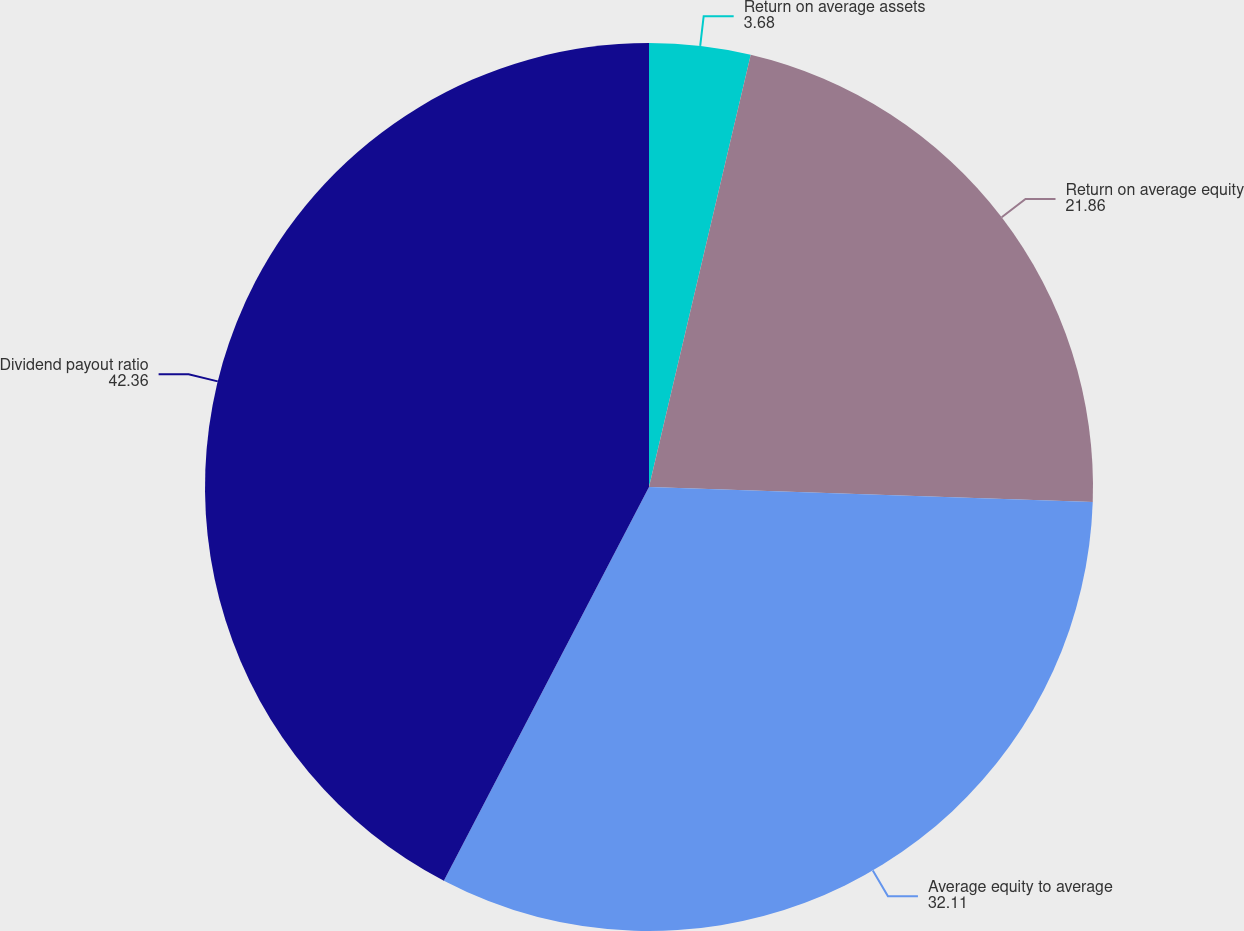<chart> <loc_0><loc_0><loc_500><loc_500><pie_chart><fcel>Return on average assets<fcel>Return on average equity<fcel>Average equity to average<fcel>Dividend payout ratio<nl><fcel>3.68%<fcel>21.86%<fcel>32.11%<fcel>42.36%<nl></chart> 